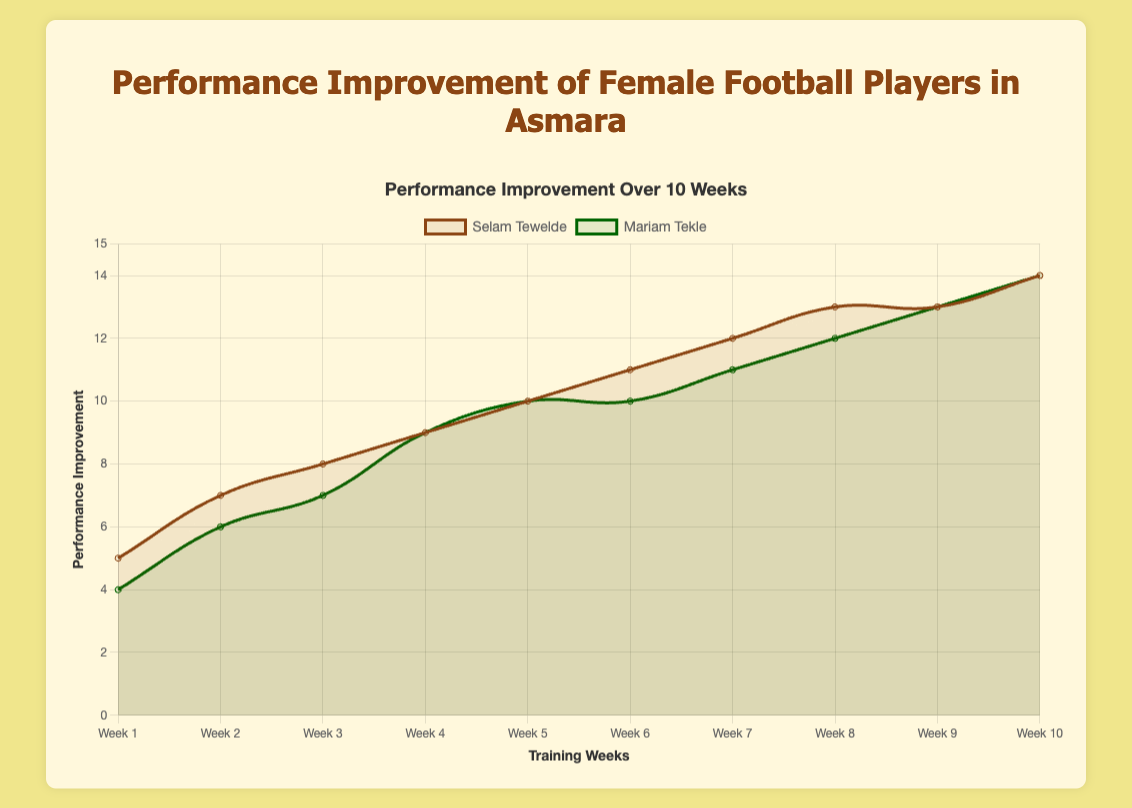Which player had a higher performance improvement in Week 2? Comparing the performance improvement of both players in Week 2, Selam Tewelde had an improvement of 7, while Mariam Tekle had an improvement of 6.
Answer: Selam Tewelde What is the total performance improvement for Selam Tewelde over the first four weeks? The performance improvements for Selam in the first four weeks are 5, 7, 8, and 9. Adding these values: 5 + 7 + 8 + 9 = 29.
Answer: 29 Between which weeks did Mariam Tekle have the greatest increase in performance improvement? By analyzing the performance improvements for Mariam over the weeks: 4, 6, 7, 9, 10, 11, 12, 13, 13, and 14, the greatest increase is between Week 1 (4) and Week 2 (6), and between Week 7 (12) and Week 8 (13), both increases being 2 points.
Answer: Weeks 1-2 and 7-8 How many weeks did both players have the same performance improvement? By reviewing the chart, both players have the same improvement in Weeks 4, 5, 8, 9, and 10. That counts as 5 weeks.
Answer: 5 By how much did Selam Tewelde's performance improvement increase from Week 5 to Week 6? Selam Tewelde's performance increased from 10 in Week 5 to 11 in Week 6. The increase is 11 - 10 = 1.
Answer: 1 On which week did Selam Tewelde first achieve a performance improvement of 10? According to the chart, Selam Tewelde first achieved a performance improvement of 10 in Week 5.
Answer: Week 5 Which player's performance improvement plateaued at 13 for two consecutive weeks, and which weeks were they? Selam Tewelde's performance improvement plateaued at 13 in Weeks 8 and 9.
Answer: Selam Tewelde, Weeks 8-9 What is the average performance improvement for Mariam Tekle over the 10 weeks? Adding up Mariam's improvements for the 10 weeks: 4 + 6 + 7 + 9 + 10 + 10 + 11 + 12 + 13 + 14 = 96. The average is 96 / 10 = 9.6.
Answer: 9.6 Did Mariam Tekle ever surpass Selam Tewelde in performance improvement in any given week? By comparing each week's performance improvement values from the chart, Mariam Tekle never surpassed Selam Tewelde in any week.
Answer: No 